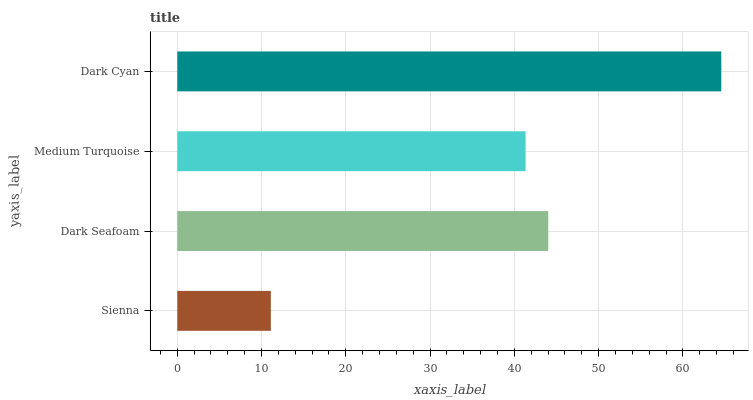Is Sienna the minimum?
Answer yes or no. Yes. Is Dark Cyan the maximum?
Answer yes or no. Yes. Is Dark Seafoam the minimum?
Answer yes or no. No. Is Dark Seafoam the maximum?
Answer yes or no. No. Is Dark Seafoam greater than Sienna?
Answer yes or no. Yes. Is Sienna less than Dark Seafoam?
Answer yes or no. Yes. Is Sienna greater than Dark Seafoam?
Answer yes or no. No. Is Dark Seafoam less than Sienna?
Answer yes or no. No. Is Dark Seafoam the high median?
Answer yes or no. Yes. Is Medium Turquoise the low median?
Answer yes or no. Yes. Is Dark Cyan the high median?
Answer yes or no. No. Is Sienna the low median?
Answer yes or no. No. 